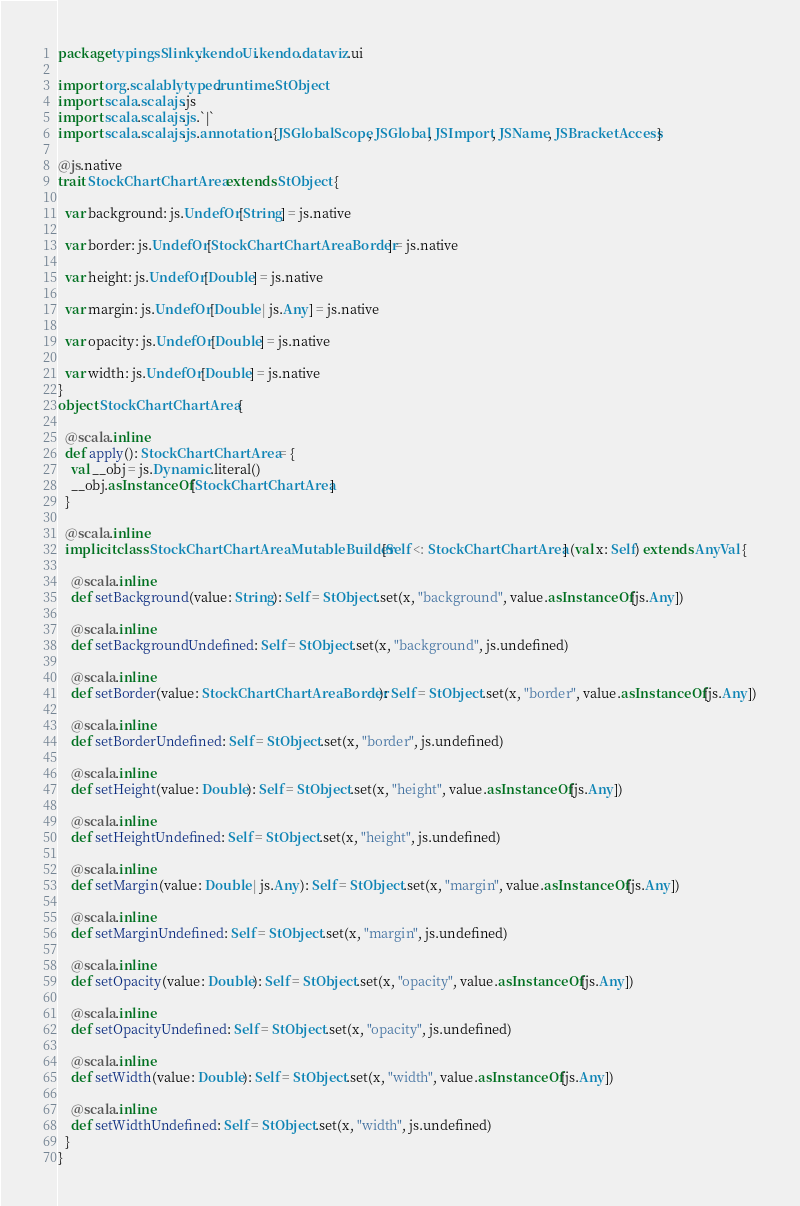Convert code to text. <code><loc_0><loc_0><loc_500><loc_500><_Scala_>package typingsSlinky.kendoUi.kendo.dataviz.ui

import org.scalablytyped.runtime.StObject
import scala.scalajs.js
import scala.scalajs.js.`|`
import scala.scalajs.js.annotation.{JSGlobalScope, JSGlobal, JSImport, JSName, JSBracketAccess}

@js.native
trait StockChartChartArea extends StObject {
  
  var background: js.UndefOr[String] = js.native
  
  var border: js.UndefOr[StockChartChartAreaBorder] = js.native
  
  var height: js.UndefOr[Double] = js.native
  
  var margin: js.UndefOr[Double | js.Any] = js.native
  
  var opacity: js.UndefOr[Double] = js.native
  
  var width: js.UndefOr[Double] = js.native
}
object StockChartChartArea {
  
  @scala.inline
  def apply(): StockChartChartArea = {
    val __obj = js.Dynamic.literal()
    __obj.asInstanceOf[StockChartChartArea]
  }
  
  @scala.inline
  implicit class StockChartChartAreaMutableBuilder[Self <: StockChartChartArea] (val x: Self) extends AnyVal {
    
    @scala.inline
    def setBackground(value: String): Self = StObject.set(x, "background", value.asInstanceOf[js.Any])
    
    @scala.inline
    def setBackgroundUndefined: Self = StObject.set(x, "background", js.undefined)
    
    @scala.inline
    def setBorder(value: StockChartChartAreaBorder): Self = StObject.set(x, "border", value.asInstanceOf[js.Any])
    
    @scala.inline
    def setBorderUndefined: Self = StObject.set(x, "border", js.undefined)
    
    @scala.inline
    def setHeight(value: Double): Self = StObject.set(x, "height", value.asInstanceOf[js.Any])
    
    @scala.inline
    def setHeightUndefined: Self = StObject.set(x, "height", js.undefined)
    
    @scala.inline
    def setMargin(value: Double | js.Any): Self = StObject.set(x, "margin", value.asInstanceOf[js.Any])
    
    @scala.inline
    def setMarginUndefined: Self = StObject.set(x, "margin", js.undefined)
    
    @scala.inline
    def setOpacity(value: Double): Self = StObject.set(x, "opacity", value.asInstanceOf[js.Any])
    
    @scala.inline
    def setOpacityUndefined: Self = StObject.set(x, "opacity", js.undefined)
    
    @scala.inline
    def setWidth(value: Double): Self = StObject.set(x, "width", value.asInstanceOf[js.Any])
    
    @scala.inline
    def setWidthUndefined: Self = StObject.set(x, "width", js.undefined)
  }
}
</code> 